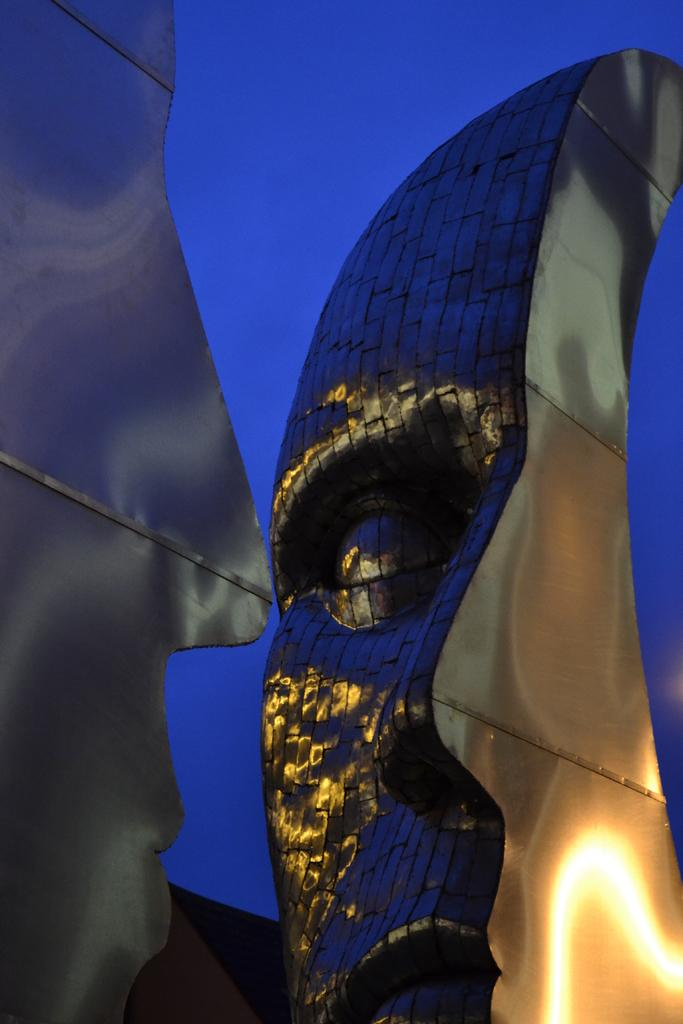What type of sculptures can be seen in the image? There are steel sculptures in the image. What color is the background of the image? The background of the image is blue. How many sheep are present in the image? There are no sheep present in the image; it features steel sculptures and a blue background. Who is the partner of the person in the image? There is no person present in the image, only steel sculptures and a blue background. 